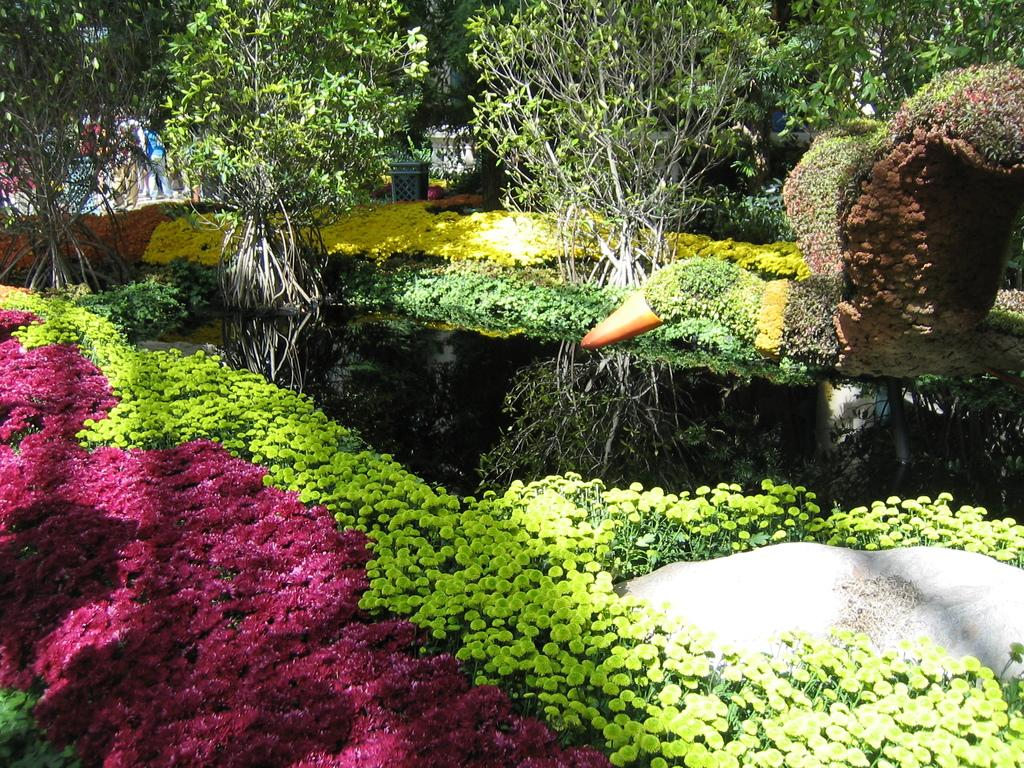What is the main feature in the center of the image? There is a pond in the center of the image. What type of vegetation can be seen in the image? There are shrubs, plants, and trees in the image. Can you describe the background of the image? There are trees and bushes in the background of the image. What type of cup is being used to catch the attention of the animals in the image? There is no cup present in the image, nor is there any indication of animals or an attempt to catch their attention. 